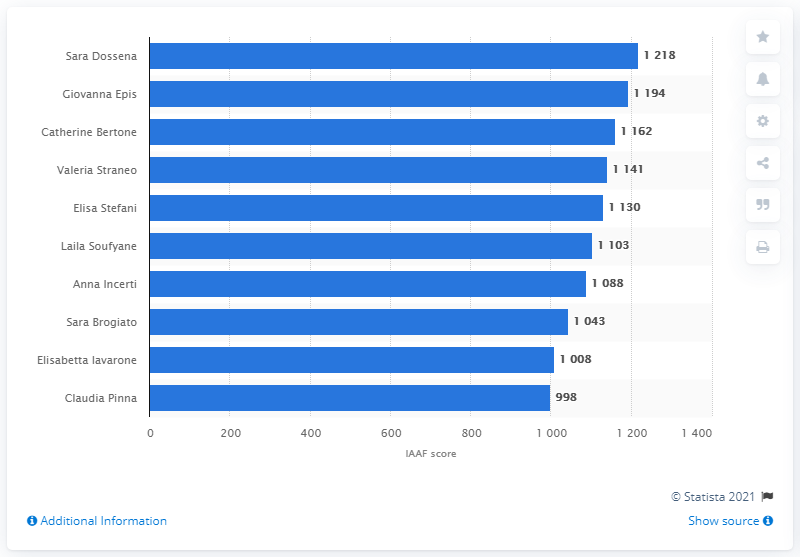Give some essential details in this illustration. According to the IAAF ranking, Giovanna Epifani ranked second. As of December 2020, Sara Dossena, an Italian female runner, had the highest number of ranking points in both the women's marathon and half marathon. 